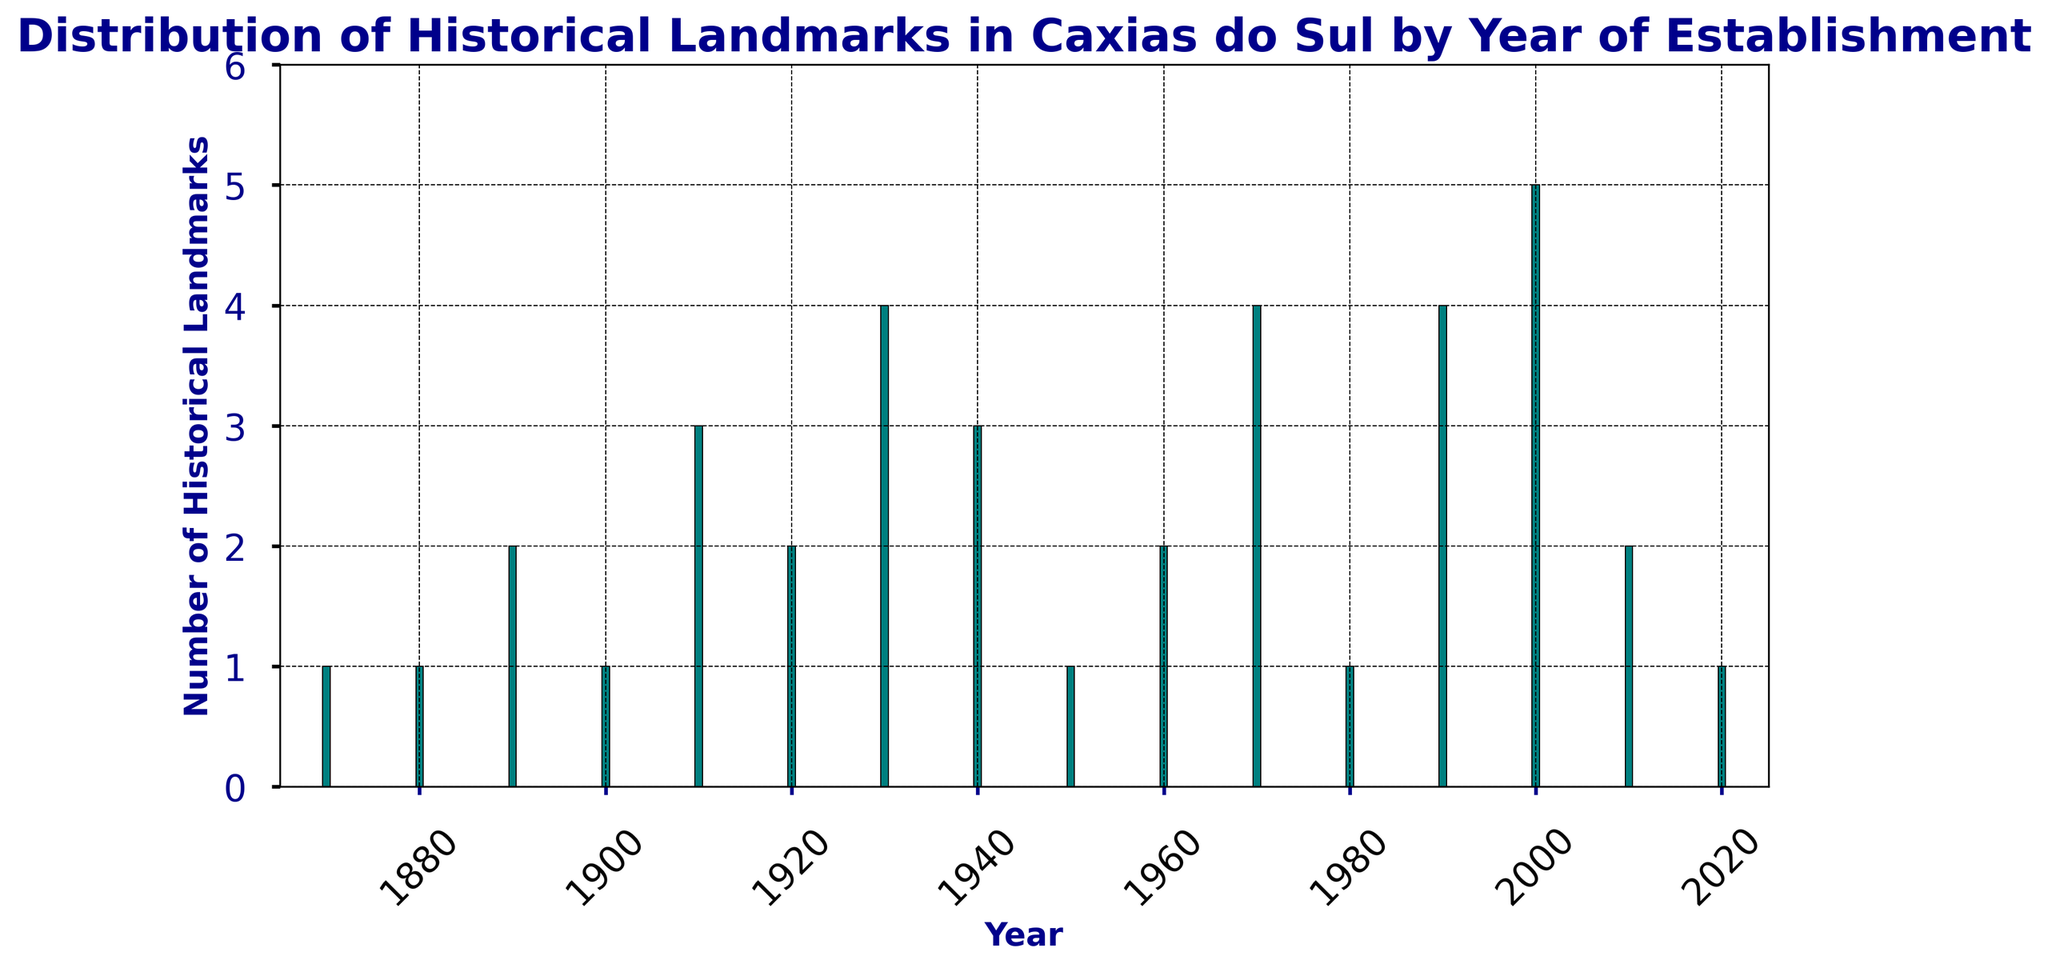What's the total number of historical landmarks established between 1900 and 1940? Add the values from the years 1900, 1910, 1920, 1930, and 1940. The total is 1 + 3 + 2 + 4 + 3 = 13.
Answer: 13 Which decade saw the highest number of historical landmarks established? Identify the decade with the tallest bar visually. The year 2000 has the tallest bar with 5 landmarks.
Answer: 2000 Are there more historical landmarks established in the 1980s or the 1990s? Compare the number of landmarks between the two decades. The 1980s have 1, while the 1990s have 4.
Answer: 1990s Which years have the same number of historical landmarks established? Identify the years with bars of the same height. The years 1890 and 1960 each have 2 landmarks, while 1910 and 1940 each have 3 landmarks, and 1930, 1970, and 1990 each have 4 landmarks.
Answer: 1890 and 1960 (2), 1910 and 1940 (3), 1930, 1970, and 1990 (4) What is the average number of historical landmarks established per decade? Sum the total number of landmarks (34) and divide by the number of decades (16). The average is 34/16 = 2.125.
Answer: 2.125 How does the number of historical landmarks established in the 1870s compare to those in the 2020s? Both the 1870s and the 2020s have 1 historical landmark established.
Answer: Equal (1) In which year were exactly 4 historical landmarks established? Identify the year(s) with a bar height of 4. The years are 1930, 1970, and 1990.
Answer: 1930, 1970, 1990 What is the difference in the number of historical landmarks established between the year 1890 and 2000? Subtract the number in 1890 (2) from the number in 2000 (5). The difference is 5 - 2 = 3.
Answer: 3 Which year has the least number of historical landmarks established, and how many were there? Identify the shortest bar. The years 1870, 1880, 1900, 1950, 1980, and 2020 each have 1 historical landmark.
Answer: 1870, 1880, 1900, 1950, 1980, 2020 (1 each) What trend or pattern do you notice in the number of historical landmarks established over the years? Observing the bars, there is an overall gradual increase in the number of historical landmarks with a few peaks, such as in 1930, 1990, and 2000.
Answer: Gradual increase with peaks 